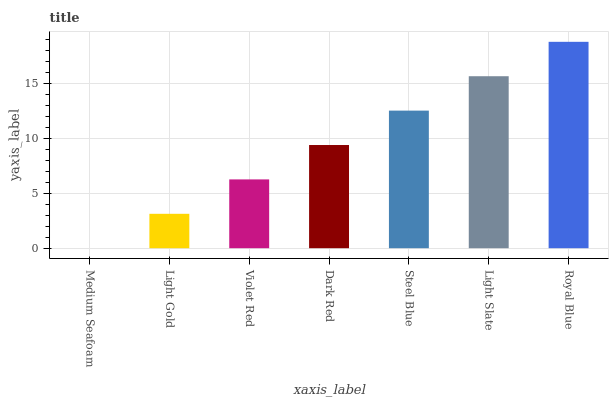Is Medium Seafoam the minimum?
Answer yes or no. Yes. Is Royal Blue the maximum?
Answer yes or no. Yes. Is Light Gold the minimum?
Answer yes or no. No. Is Light Gold the maximum?
Answer yes or no. No. Is Light Gold greater than Medium Seafoam?
Answer yes or no. Yes. Is Medium Seafoam less than Light Gold?
Answer yes or no. Yes. Is Medium Seafoam greater than Light Gold?
Answer yes or no. No. Is Light Gold less than Medium Seafoam?
Answer yes or no. No. Is Dark Red the high median?
Answer yes or no. Yes. Is Dark Red the low median?
Answer yes or no. Yes. Is Violet Red the high median?
Answer yes or no. No. Is Light Gold the low median?
Answer yes or no. No. 